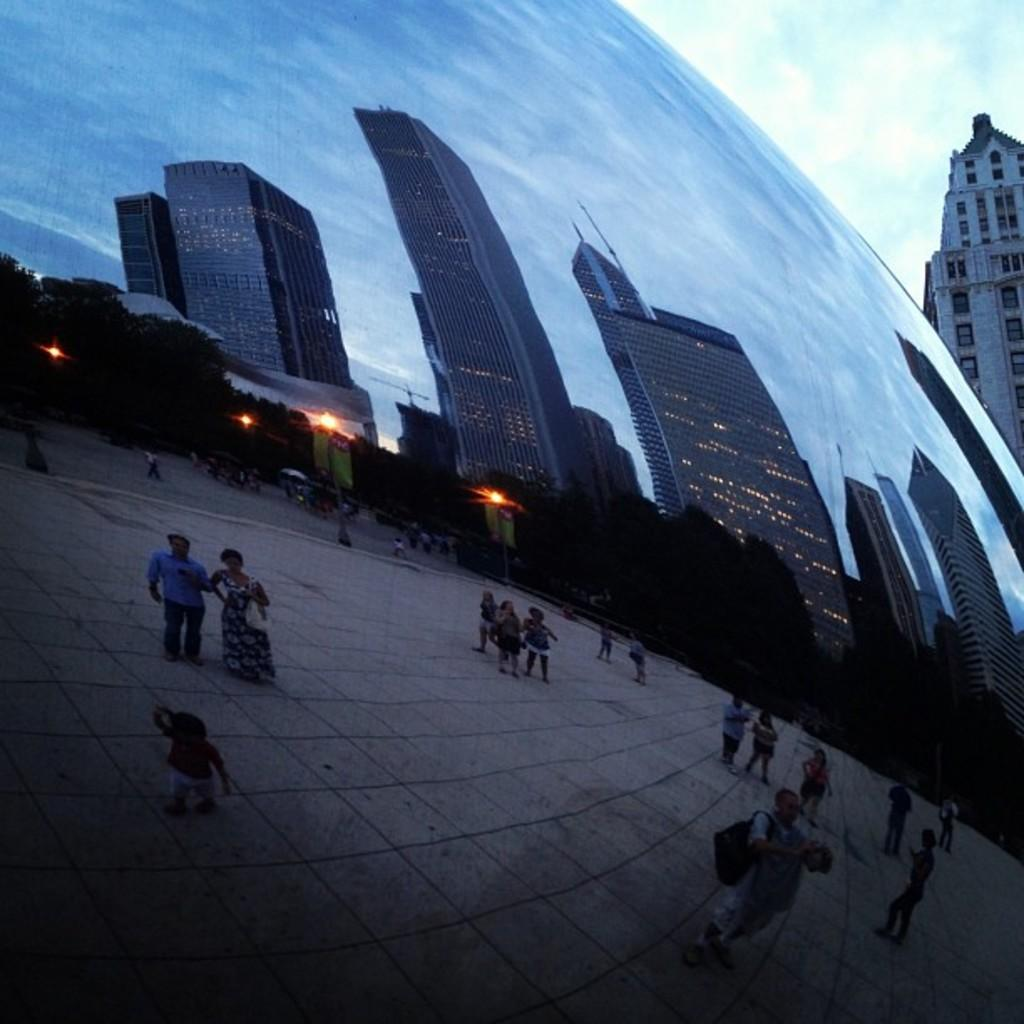What type of structures can be seen in the image? There are buildings in the image. What natural elements are present in the image? There are trees in the image. What artificial elements are present in the image? There are lights in the image. Who or what else can be seen in the image? There are people in the image. What is visible at the top of the image? The sky is visible at the top of the image. What type of crow can be seen flying through the mist in the image? There is no crow or mist present in the image. Can you tell me how many dogs are walking in the image? There are no dogs present in the image. 